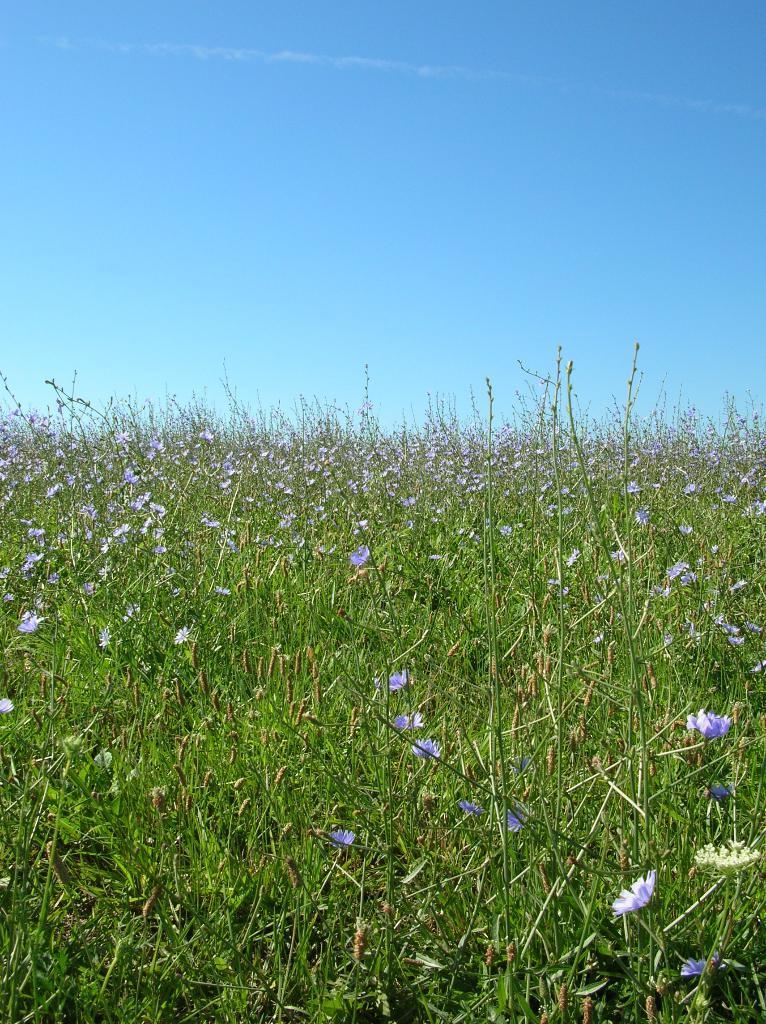Describe this image in one or two sentences. We can see plants and flowers. We can see sky in blue color. 